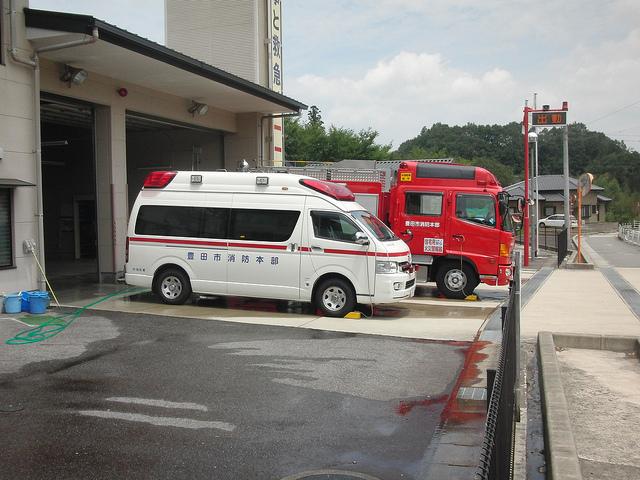How many vehicles are pictures?
Answer briefly. 3. Are the car doors all shut?
Concise answer only. Yes. Where is the EMT truck?
Be succinct. Parked. Are these vehicles in the United States?
Short answer required. No. What kind of vehicle is parked next to the truck?
Write a very short answer. Ambulance. Why are the lights on the ambulance on?
Short answer required. Emergency. Are these the police?
Quick response, please. No. Why is there a fire truck on the scene?
Keep it brief. Station. What is this place called?
Be succinct. Fire station. Is the white van an ambulance?
Be succinct. Yes. What material is the planters made of?
Quick response, please. Plastic. 